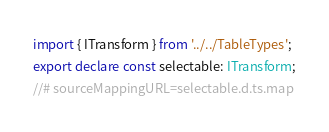Convert code to text. <code><loc_0><loc_0><loc_500><loc_500><_TypeScript_>import { ITransform } from '../../TableTypes';
export declare const selectable: ITransform;
//# sourceMappingURL=selectable.d.ts.map</code> 